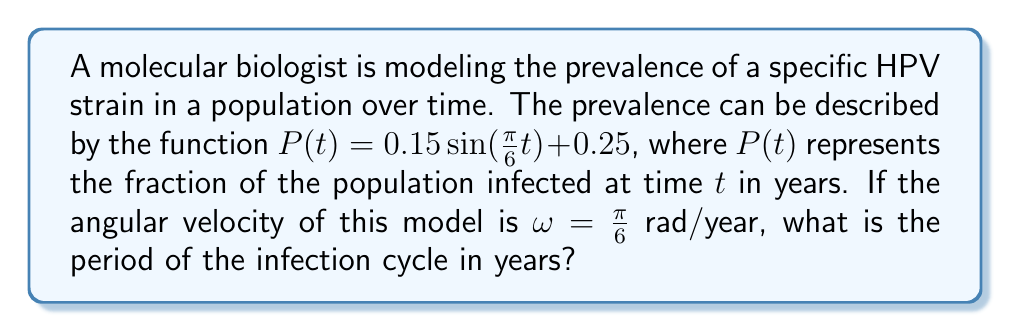What is the answer to this math problem? To find the period of the infection cycle, we need to understand the relationship between angular velocity and period in sinusoidal functions.

1) The general form of a sinusoidal function is:
   $f(t) = A \sin(\omega t + \phi) + B$

   Where:
   $A$ is the amplitude
   $\omega$ is the angular velocity
   $\phi$ is the phase shift
   $B$ is the vertical shift

2) In our case, $\omega = \frac{\pi}{6}$ rad/year

3) The relationship between angular velocity ($\omega$) and period ($T$) is:
   $\omega = \frac{2\pi}{T}$

4) We can rearrange this to solve for $T$:
   $T = \frac{2\pi}{\omega}$

5) Substituting our known value of $\omega$:
   $T = \frac{2\pi}{\frac{\pi}{6}}$

6) Simplify:
   $T = 2\pi \cdot \frac{6}{\pi} = 12$

Therefore, the period of the infection cycle is 12 years.
Answer: 12 years 